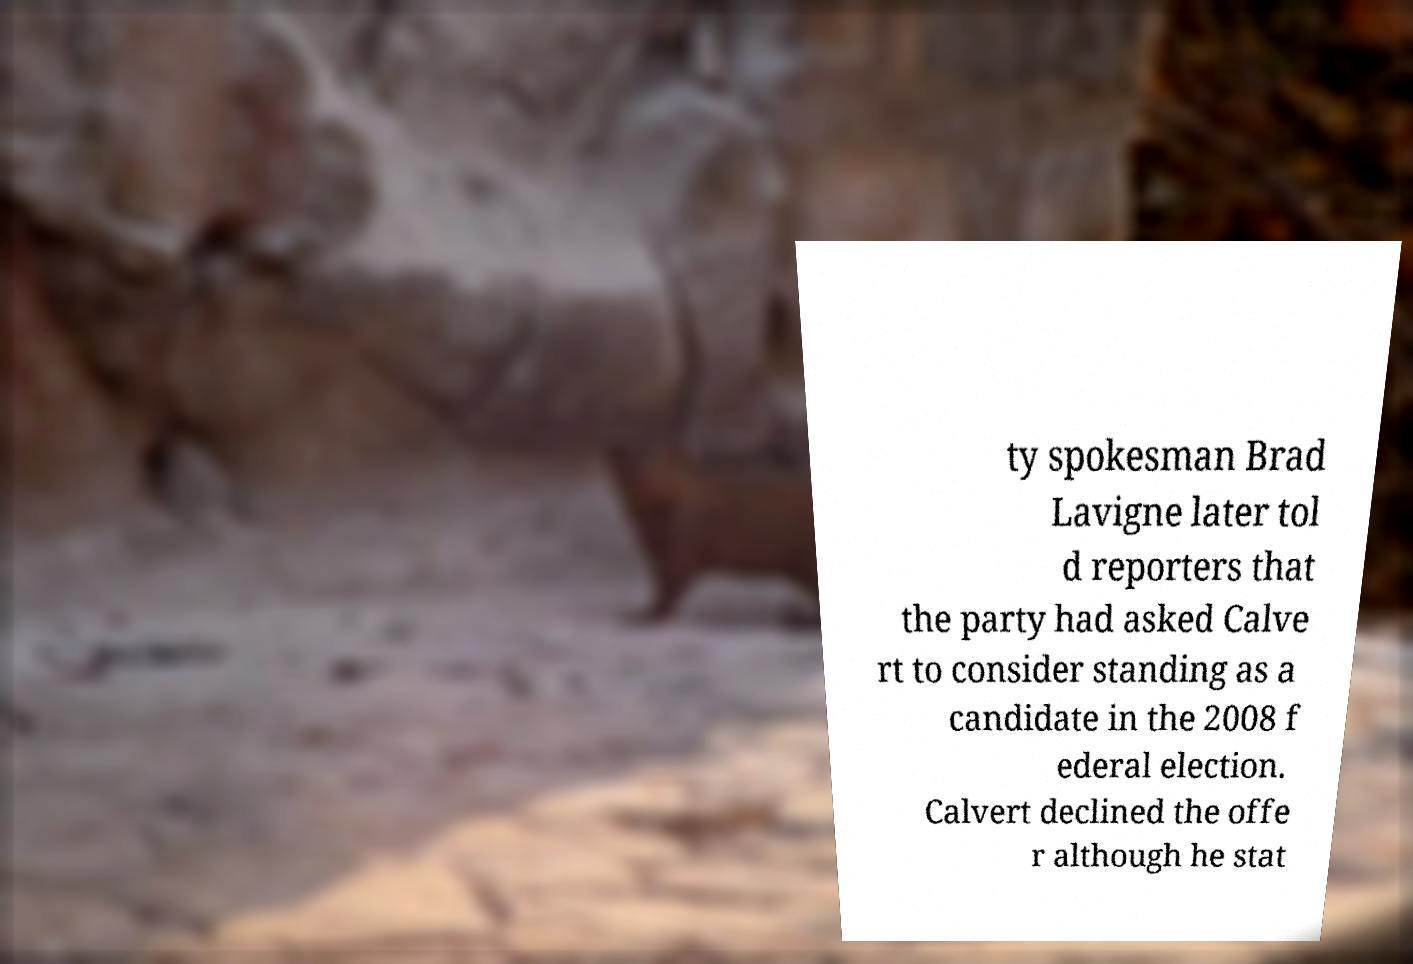Could you extract and type out the text from this image? ty spokesman Brad Lavigne later tol d reporters that the party had asked Calve rt to consider standing as a candidate in the 2008 f ederal election. Calvert declined the offe r although he stat 